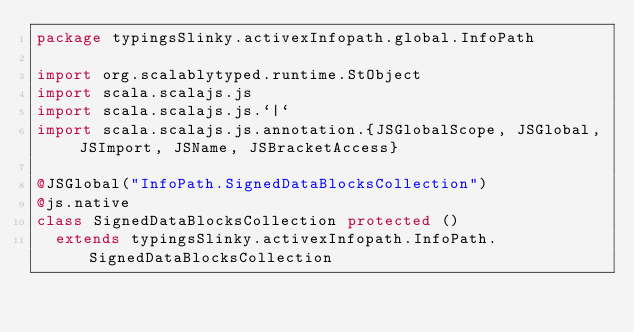<code> <loc_0><loc_0><loc_500><loc_500><_Scala_>package typingsSlinky.activexInfopath.global.InfoPath

import org.scalablytyped.runtime.StObject
import scala.scalajs.js
import scala.scalajs.js.`|`
import scala.scalajs.js.annotation.{JSGlobalScope, JSGlobal, JSImport, JSName, JSBracketAccess}

@JSGlobal("InfoPath.SignedDataBlocksCollection")
@js.native
class SignedDataBlocksCollection protected ()
  extends typingsSlinky.activexInfopath.InfoPath.SignedDataBlocksCollection
</code> 